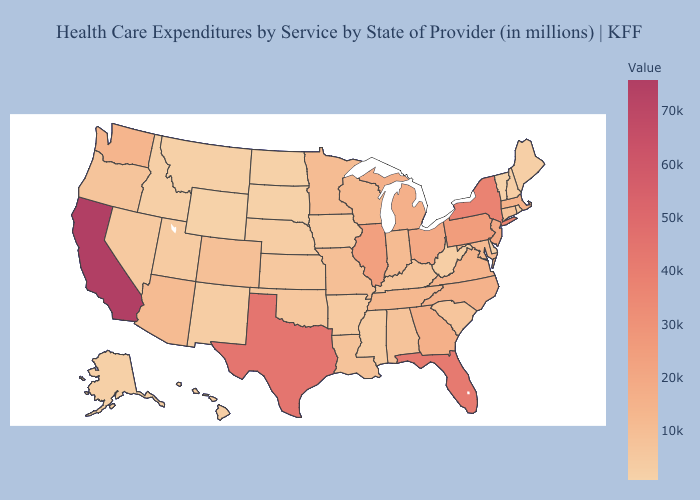Does the map have missing data?
Answer briefly. No. Among the states that border Kansas , does Colorado have the highest value?
Give a very brief answer. No. Does Texas have the highest value in the South?
Be succinct. Yes. Which states hav the highest value in the West?
Be succinct. California. 